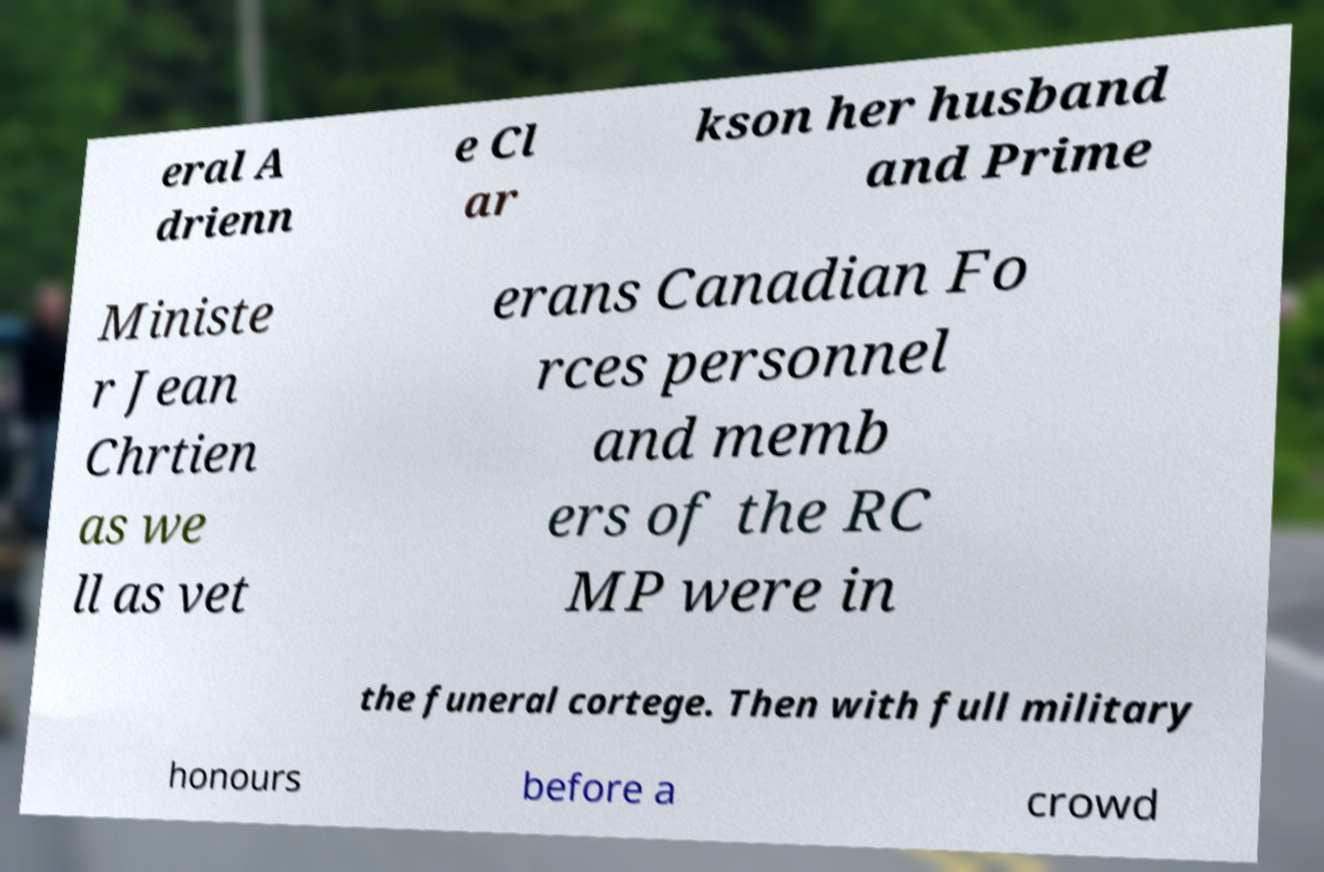What messages or text are displayed in this image? I need them in a readable, typed format. eral A drienn e Cl ar kson her husband and Prime Ministe r Jean Chrtien as we ll as vet erans Canadian Fo rces personnel and memb ers of the RC MP were in the funeral cortege. Then with full military honours before a crowd 